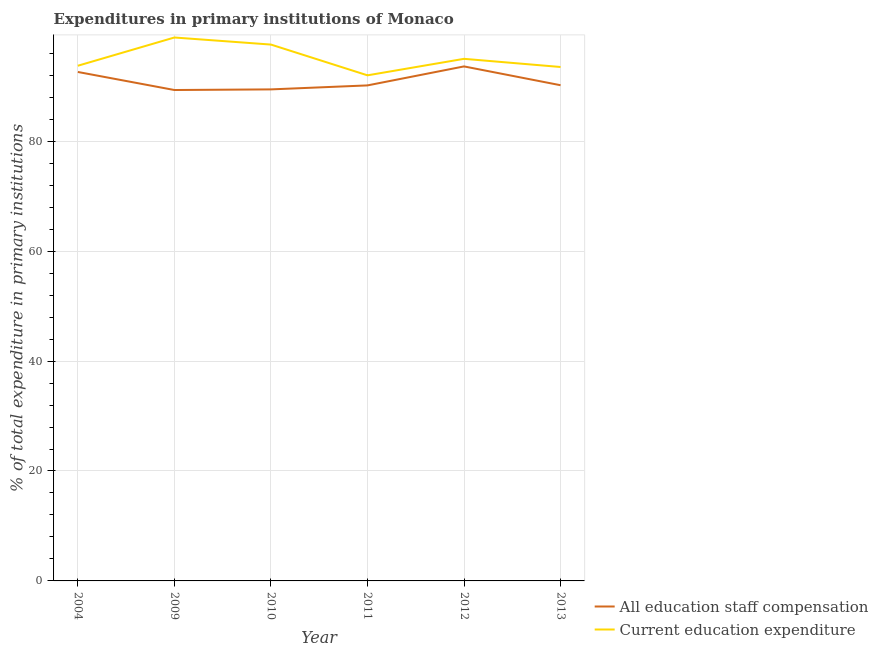What is the expenditure in staff compensation in 2012?
Make the answer very short. 93.61. Across all years, what is the maximum expenditure in education?
Provide a succinct answer. 98.87. Across all years, what is the minimum expenditure in education?
Your response must be concise. 91.98. In which year was the expenditure in education maximum?
Provide a short and direct response. 2009. In which year was the expenditure in education minimum?
Provide a succinct answer. 2011. What is the total expenditure in staff compensation in the graph?
Give a very brief answer. 545.27. What is the difference between the expenditure in staff compensation in 2004 and that in 2013?
Keep it short and to the point. 2.41. What is the difference between the expenditure in staff compensation in 2004 and the expenditure in education in 2013?
Give a very brief answer. -0.9. What is the average expenditure in staff compensation per year?
Offer a terse response. 90.88. In the year 2011, what is the difference between the expenditure in education and expenditure in staff compensation?
Keep it short and to the point. 1.83. In how many years, is the expenditure in education greater than 36 %?
Ensure brevity in your answer.  6. What is the ratio of the expenditure in staff compensation in 2010 to that in 2011?
Ensure brevity in your answer.  0.99. What is the difference between the highest and the second highest expenditure in education?
Provide a succinct answer. 1.29. What is the difference between the highest and the lowest expenditure in staff compensation?
Provide a short and direct response. 4.29. Is the expenditure in staff compensation strictly greater than the expenditure in education over the years?
Your response must be concise. No. How many years are there in the graph?
Provide a succinct answer. 6. What is the difference between two consecutive major ticks on the Y-axis?
Your answer should be compact. 20. Does the graph contain any zero values?
Provide a succinct answer. No. How are the legend labels stacked?
Keep it short and to the point. Vertical. What is the title of the graph?
Make the answer very short. Expenditures in primary institutions of Monaco. What is the label or title of the Y-axis?
Offer a terse response. % of total expenditure in primary institutions. What is the % of total expenditure in primary institutions of All education staff compensation in 2004?
Make the answer very short. 92.59. What is the % of total expenditure in primary institutions of Current education expenditure in 2004?
Give a very brief answer. 93.73. What is the % of total expenditure in primary institutions in All education staff compensation in 2009?
Ensure brevity in your answer.  89.31. What is the % of total expenditure in primary institutions of Current education expenditure in 2009?
Provide a short and direct response. 98.87. What is the % of total expenditure in primary institutions of All education staff compensation in 2010?
Keep it short and to the point. 89.43. What is the % of total expenditure in primary institutions of Current education expenditure in 2010?
Your response must be concise. 97.58. What is the % of total expenditure in primary institutions of All education staff compensation in 2011?
Ensure brevity in your answer.  90.15. What is the % of total expenditure in primary institutions of Current education expenditure in 2011?
Offer a very short reply. 91.98. What is the % of total expenditure in primary institutions in All education staff compensation in 2012?
Your answer should be compact. 93.61. What is the % of total expenditure in primary institutions of Current education expenditure in 2012?
Your answer should be compact. 94.99. What is the % of total expenditure in primary institutions of All education staff compensation in 2013?
Your answer should be very brief. 90.18. What is the % of total expenditure in primary institutions of Current education expenditure in 2013?
Offer a very short reply. 93.5. Across all years, what is the maximum % of total expenditure in primary institutions of All education staff compensation?
Your answer should be compact. 93.61. Across all years, what is the maximum % of total expenditure in primary institutions in Current education expenditure?
Offer a terse response. 98.87. Across all years, what is the minimum % of total expenditure in primary institutions of All education staff compensation?
Make the answer very short. 89.31. Across all years, what is the minimum % of total expenditure in primary institutions of Current education expenditure?
Your answer should be very brief. 91.98. What is the total % of total expenditure in primary institutions of All education staff compensation in the graph?
Provide a succinct answer. 545.27. What is the total % of total expenditure in primary institutions in Current education expenditure in the graph?
Your answer should be compact. 570.64. What is the difference between the % of total expenditure in primary institutions in All education staff compensation in 2004 and that in 2009?
Your response must be concise. 3.28. What is the difference between the % of total expenditure in primary institutions in Current education expenditure in 2004 and that in 2009?
Your answer should be very brief. -5.14. What is the difference between the % of total expenditure in primary institutions in All education staff compensation in 2004 and that in 2010?
Your answer should be very brief. 3.17. What is the difference between the % of total expenditure in primary institutions of Current education expenditure in 2004 and that in 2010?
Ensure brevity in your answer.  -3.85. What is the difference between the % of total expenditure in primary institutions in All education staff compensation in 2004 and that in 2011?
Keep it short and to the point. 2.44. What is the difference between the % of total expenditure in primary institutions in Current education expenditure in 2004 and that in 2011?
Ensure brevity in your answer.  1.74. What is the difference between the % of total expenditure in primary institutions of All education staff compensation in 2004 and that in 2012?
Keep it short and to the point. -1.01. What is the difference between the % of total expenditure in primary institutions in Current education expenditure in 2004 and that in 2012?
Ensure brevity in your answer.  -1.26. What is the difference between the % of total expenditure in primary institutions in All education staff compensation in 2004 and that in 2013?
Your answer should be compact. 2.41. What is the difference between the % of total expenditure in primary institutions in Current education expenditure in 2004 and that in 2013?
Your response must be concise. 0.23. What is the difference between the % of total expenditure in primary institutions of All education staff compensation in 2009 and that in 2010?
Make the answer very short. -0.12. What is the difference between the % of total expenditure in primary institutions in Current education expenditure in 2009 and that in 2010?
Make the answer very short. 1.29. What is the difference between the % of total expenditure in primary institutions in All education staff compensation in 2009 and that in 2011?
Keep it short and to the point. -0.84. What is the difference between the % of total expenditure in primary institutions of Current education expenditure in 2009 and that in 2011?
Your answer should be compact. 6.88. What is the difference between the % of total expenditure in primary institutions of All education staff compensation in 2009 and that in 2012?
Ensure brevity in your answer.  -4.29. What is the difference between the % of total expenditure in primary institutions of Current education expenditure in 2009 and that in 2012?
Your answer should be compact. 3.88. What is the difference between the % of total expenditure in primary institutions in All education staff compensation in 2009 and that in 2013?
Provide a succinct answer. -0.87. What is the difference between the % of total expenditure in primary institutions in Current education expenditure in 2009 and that in 2013?
Keep it short and to the point. 5.37. What is the difference between the % of total expenditure in primary institutions of All education staff compensation in 2010 and that in 2011?
Offer a very short reply. -0.72. What is the difference between the % of total expenditure in primary institutions in Current education expenditure in 2010 and that in 2011?
Ensure brevity in your answer.  5.6. What is the difference between the % of total expenditure in primary institutions in All education staff compensation in 2010 and that in 2012?
Your response must be concise. -4.18. What is the difference between the % of total expenditure in primary institutions of Current education expenditure in 2010 and that in 2012?
Your response must be concise. 2.59. What is the difference between the % of total expenditure in primary institutions of All education staff compensation in 2010 and that in 2013?
Offer a very short reply. -0.76. What is the difference between the % of total expenditure in primary institutions in Current education expenditure in 2010 and that in 2013?
Your response must be concise. 4.08. What is the difference between the % of total expenditure in primary institutions in All education staff compensation in 2011 and that in 2012?
Offer a very short reply. -3.46. What is the difference between the % of total expenditure in primary institutions of Current education expenditure in 2011 and that in 2012?
Provide a short and direct response. -3. What is the difference between the % of total expenditure in primary institutions in All education staff compensation in 2011 and that in 2013?
Ensure brevity in your answer.  -0.03. What is the difference between the % of total expenditure in primary institutions in Current education expenditure in 2011 and that in 2013?
Provide a succinct answer. -1.52. What is the difference between the % of total expenditure in primary institutions of All education staff compensation in 2012 and that in 2013?
Keep it short and to the point. 3.42. What is the difference between the % of total expenditure in primary institutions in Current education expenditure in 2012 and that in 2013?
Your response must be concise. 1.49. What is the difference between the % of total expenditure in primary institutions of All education staff compensation in 2004 and the % of total expenditure in primary institutions of Current education expenditure in 2009?
Offer a very short reply. -6.27. What is the difference between the % of total expenditure in primary institutions of All education staff compensation in 2004 and the % of total expenditure in primary institutions of Current education expenditure in 2010?
Your answer should be very brief. -4.99. What is the difference between the % of total expenditure in primary institutions of All education staff compensation in 2004 and the % of total expenditure in primary institutions of Current education expenditure in 2011?
Ensure brevity in your answer.  0.61. What is the difference between the % of total expenditure in primary institutions in All education staff compensation in 2004 and the % of total expenditure in primary institutions in Current education expenditure in 2012?
Your answer should be very brief. -2.39. What is the difference between the % of total expenditure in primary institutions of All education staff compensation in 2004 and the % of total expenditure in primary institutions of Current education expenditure in 2013?
Provide a succinct answer. -0.9. What is the difference between the % of total expenditure in primary institutions in All education staff compensation in 2009 and the % of total expenditure in primary institutions in Current education expenditure in 2010?
Give a very brief answer. -8.27. What is the difference between the % of total expenditure in primary institutions in All education staff compensation in 2009 and the % of total expenditure in primary institutions in Current education expenditure in 2011?
Your answer should be very brief. -2.67. What is the difference between the % of total expenditure in primary institutions in All education staff compensation in 2009 and the % of total expenditure in primary institutions in Current education expenditure in 2012?
Offer a terse response. -5.67. What is the difference between the % of total expenditure in primary institutions of All education staff compensation in 2009 and the % of total expenditure in primary institutions of Current education expenditure in 2013?
Offer a very short reply. -4.19. What is the difference between the % of total expenditure in primary institutions of All education staff compensation in 2010 and the % of total expenditure in primary institutions of Current education expenditure in 2011?
Provide a short and direct response. -2.56. What is the difference between the % of total expenditure in primary institutions of All education staff compensation in 2010 and the % of total expenditure in primary institutions of Current education expenditure in 2012?
Provide a short and direct response. -5.56. What is the difference between the % of total expenditure in primary institutions of All education staff compensation in 2010 and the % of total expenditure in primary institutions of Current education expenditure in 2013?
Provide a succinct answer. -4.07. What is the difference between the % of total expenditure in primary institutions in All education staff compensation in 2011 and the % of total expenditure in primary institutions in Current education expenditure in 2012?
Offer a very short reply. -4.84. What is the difference between the % of total expenditure in primary institutions in All education staff compensation in 2011 and the % of total expenditure in primary institutions in Current education expenditure in 2013?
Ensure brevity in your answer.  -3.35. What is the difference between the % of total expenditure in primary institutions in All education staff compensation in 2012 and the % of total expenditure in primary institutions in Current education expenditure in 2013?
Make the answer very short. 0.11. What is the average % of total expenditure in primary institutions in All education staff compensation per year?
Offer a terse response. 90.88. What is the average % of total expenditure in primary institutions in Current education expenditure per year?
Provide a short and direct response. 95.11. In the year 2004, what is the difference between the % of total expenditure in primary institutions of All education staff compensation and % of total expenditure in primary institutions of Current education expenditure?
Make the answer very short. -1.13. In the year 2009, what is the difference between the % of total expenditure in primary institutions in All education staff compensation and % of total expenditure in primary institutions in Current education expenditure?
Provide a succinct answer. -9.55. In the year 2010, what is the difference between the % of total expenditure in primary institutions of All education staff compensation and % of total expenditure in primary institutions of Current education expenditure?
Offer a terse response. -8.15. In the year 2011, what is the difference between the % of total expenditure in primary institutions of All education staff compensation and % of total expenditure in primary institutions of Current education expenditure?
Your response must be concise. -1.83. In the year 2012, what is the difference between the % of total expenditure in primary institutions of All education staff compensation and % of total expenditure in primary institutions of Current education expenditure?
Ensure brevity in your answer.  -1.38. In the year 2013, what is the difference between the % of total expenditure in primary institutions of All education staff compensation and % of total expenditure in primary institutions of Current education expenditure?
Keep it short and to the point. -3.32. What is the ratio of the % of total expenditure in primary institutions in All education staff compensation in 2004 to that in 2009?
Make the answer very short. 1.04. What is the ratio of the % of total expenditure in primary institutions in Current education expenditure in 2004 to that in 2009?
Provide a succinct answer. 0.95. What is the ratio of the % of total expenditure in primary institutions of All education staff compensation in 2004 to that in 2010?
Make the answer very short. 1.04. What is the ratio of the % of total expenditure in primary institutions of Current education expenditure in 2004 to that in 2010?
Provide a short and direct response. 0.96. What is the ratio of the % of total expenditure in primary institutions in All education staff compensation in 2004 to that in 2011?
Offer a very short reply. 1.03. What is the ratio of the % of total expenditure in primary institutions of All education staff compensation in 2004 to that in 2012?
Offer a very short reply. 0.99. What is the ratio of the % of total expenditure in primary institutions in Current education expenditure in 2004 to that in 2012?
Your answer should be very brief. 0.99. What is the ratio of the % of total expenditure in primary institutions of All education staff compensation in 2004 to that in 2013?
Provide a succinct answer. 1.03. What is the ratio of the % of total expenditure in primary institutions in Current education expenditure in 2004 to that in 2013?
Offer a terse response. 1. What is the ratio of the % of total expenditure in primary institutions in All education staff compensation in 2009 to that in 2010?
Your answer should be very brief. 1. What is the ratio of the % of total expenditure in primary institutions in Current education expenditure in 2009 to that in 2010?
Your answer should be very brief. 1.01. What is the ratio of the % of total expenditure in primary institutions in All education staff compensation in 2009 to that in 2011?
Give a very brief answer. 0.99. What is the ratio of the % of total expenditure in primary institutions in Current education expenditure in 2009 to that in 2011?
Offer a terse response. 1.07. What is the ratio of the % of total expenditure in primary institutions of All education staff compensation in 2009 to that in 2012?
Make the answer very short. 0.95. What is the ratio of the % of total expenditure in primary institutions of Current education expenditure in 2009 to that in 2012?
Keep it short and to the point. 1.04. What is the ratio of the % of total expenditure in primary institutions of All education staff compensation in 2009 to that in 2013?
Provide a succinct answer. 0.99. What is the ratio of the % of total expenditure in primary institutions in Current education expenditure in 2009 to that in 2013?
Provide a short and direct response. 1.06. What is the ratio of the % of total expenditure in primary institutions in All education staff compensation in 2010 to that in 2011?
Your answer should be compact. 0.99. What is the ratio of the % of total expenditure in primary institutions in Current education expenditure in 2010 to that in 2011?
Your response must be concise. 1.06. What is the ratio of the % of total expenditure in primary institutions in All education staff compensation in 2010 to that in 2012?
Make the answer very short. 0.96. What is the ratio of the % of total expenditure in primary institutions in Current education expenditure in 2010 to that in 2012?
Offer a very short reply. 1.03. What is the ratio of the % of total expenditure in primary institutions of Current education expenditure in 2010 to that in 2013?
Ensure brevity in your answer.  1.04. What is the ratio of the % of total expenditure in primary institutions in All education staff compensation in 2011 to that in 2012?
Offer a very short reply. 0.96. What is the ratio of the % of total expenditure in primary institutions in Current education expenditure in 2011 to that in 2012?
Your answer should be compact. 0.97. What is the ratio of the % of total expenditure in primary institutions in Current education expenditure in 2011 to that in 2013?
Offer a very short reply. 0.98. What is the ratio of the % of total expenditure in primary institutions of All education staff compensation in 2012 to that in 2013?
Make the answer very short. 1.04. What is the ratio of the % of total expenditure in primary institutions of Current education expenditure in 2012 to that in 2013?
Give a very brief answer. 1.02. What is the difference between the highest and the second highest % of total expenditure in primary institutions in All education staff compensation?
Provide a succinct answer. 1.01. What is the difference between the highest and the second highest % of total expenditure in primary institutions of Current education expenditure?
Your answer should be very brief. 1.29. What is the difference between the highest and the lowest % of total expenditure in primary institutions of All education staff compensation?
Make the answer very short. 4.29. What is the difference between the highest and the lowest % of total expenditure in primary institutions in Current education expenditure?
Your answer should be very brief. 6.88. 